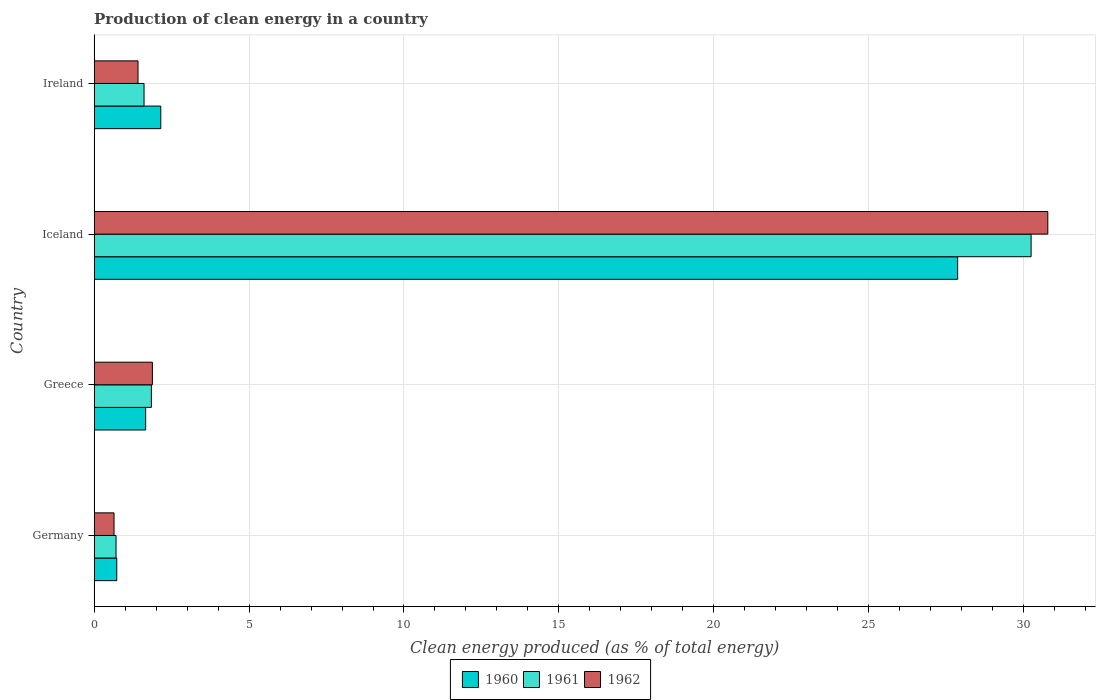How many different coloured bars are there?
Provide a succinct answer. 3. How many groups of bars are there?
Give a very brief answer. 4. How many bars are there on the 2nd tick from the top?
Provide a short and direct response. 3. How many bars are there on the 1st tick from the bottom?
Keep it short and to the point. 3. What is the label of the 1st group of bars from the top?
Provide a short and direct response. Ireland. In how many cases, is the number of bars for a given country not equal to the number of legend labels?
Offer a very short reply. 0. What is the percentage of clean energy produced in 1961 in Ireland?
Provide a succinct answer. 1.61. Across all countries, what is the maximum percentage of clean energy produced in 1961?
Give a very brief answer. 30.24. Across all countries, what is the minimum percentage of clean energy produced in 1961?
Ensure brevity in your answer.  0.7. In which country was the percentage of clean energy produced in 1961 minimum?
Keep it short and to the point. Germany. What is the total percentage of clean energy produced in 1962 in the graph?
Offer a terse response. 34.72. What is the difference between the percentage of clean energy produced in 1962 in Iceland and that in Ireland?
Your answer should be very brief. 29.37. What is the difference between the percentage of clean energy produced in 1961 in Ireland and the percentage of clean energy produced in 1962 in Germany?
Provide a short and direct response. 0.97. What is the average percentage of clean energy produced in 1962 per country?
Offer a terse response. 8.68. What is the difference between the percentage of clean energy produced in 1962 and percentage of clean energy produced in 1960 in Ireland?
Your answer should be very brief. -0.73. In how many countries, is the percentage of clean energy produced in 1962 greater than 1 %?
Keep it short and to the point. 3. What is the ratio of the percentage of clean energy produced in 1960 in Germany to that in Greece?
Your answer should be compact. 0.44. What is the difference between the highest and the second highest percentage of clean energy produced in 1961?
Offer a terse response. 28.4. What is the difference between the highest and the lowest percentage of clean energy produced in 1960?
Your answer should be very brief. 27.14. In how many countries, is the percentage of clean energy produced in 1962 greater than the average percentage of clean energy produced in 1962 taken over all countries?
Keep it short and to the point. 1. Is the sum of the percentage of clean energy produced in 1961 in Greece and Iceland greater than the maximum percentage of clean energy produced in 1960 across all countries?
Keep it short and to the point. Yes. What does the 1st bar from the top in Germany represents?
Ensure brevity in your answer.  1962. What does the 2nd bar from the bottom in Iceland represents?
Ensure brevity in your answer.  1961. Are all the bars in the graph horizontal?
Your answer should be compact. Yes. Does the graph contain grids?
Your answer should be compact. Yes. Where does the legend appear in the graph?
Provide a short and direct response. Bottom center. How many legend labels are there?
Keep it short and to the point. 3. How are the legend labels stacked?
Give a very brief answer. Horizontal. What is the title of the graph?
Your answer should be compact. Production of clean energy in a country. What is the label or title of the X-axis?
Ensure brevity in your answer.  Clean energy produced (as % of total energy). What is the Clean energy produced (as % of total energy) of 1960 in Germany?
Your response must be concise. 0.73. What is the Clean energy produced (as % of total energy) in 1961 in Germany?
Make the answer very short. 0.7. What is the Clean energy produced (as % of total energy) in 1962 in Germany?
Make the answer very short. 0.64. What is the Clean energy produced (as % of total energy) of 1960 in Greece?
Your answer should be very brief. 1.66. What is the Clean energy produced (as % of total energy) of 1961 in Greece?
Offer a very short reply. 1.84. What is the Clean energy produced (as % of total energy) in 1962 in Greece?
Your response must be concise. 1.88. What is the Clean energy produced (as % of total energy) of 1960 in Iceland?
Your answer should be compact. 27.87. What is the Clean energy produced (as % of total energy) in 1961 in Iceland?
Offer a very short reply. 30.24. What is the Clean energy produced (as % of total energy) of 1962 in Iceland?
Provide a succinct answer. 30.78. What is the Clean energy produced (as % of total energy) in 1960 in Ireland?
Make the answer very short. 2.15. What is the Clean energy produced (as % of total energy) of 1961 in Ireland?
Your answer should be compact. 1.61. What is the Clean energy produced (as % of total energy) in 1962 in Ireland?
Your answer should be compact. 1.41. Across all countries, what is the maximum Clean energy produced (as % of total energy) of 1960?
Your answer should be compact. 27.87. Across all countries, what is the maximum Clean energy produced (as % of total energy) of 1961?
Provide a short and direct response. 30.24. Across all countries, what is the maximum Clean energy produced (as % of total energy) in 1962?
Provide a short and direct response. 30.78. Across all countries, what is the minimum Clean energy produced (as % of total energy) in 1960?
Offer a very short reply. 0.73. Across all countries, what is the minimum Clean energy produced (as % of total energy) in 1961?
Provide a short and direct response. 0.7. Across all countries, what is the minimum Clean energy produced (as % of total energy) in 1962?
Your response must be concise. 0.64. What is the total Clean energy produced (as % of total energy) of 1960 in the graph?
Ensure brevity in your answer.  32.41. What is the total Clean energy produced (as % of total energy) of 1961 in the graph?
Offer a very short reply. 34.4. What is the total Clean energy produced (as % of total energy) of 1962 in the graph?
Provide a succinct answer. 34.72. What is the difference between the Clean energy produced (as % of total energy) of 1960 in Germany and that in Greece?
Your response must be concise. -0.93. What is the difference between the Clean energy produced (as % of total energy) in 1961 in Germany and that in Greece?
Make the answer very short. -1.14. What is the difference between the Clean energy produced (as % of total energy) in 1962 in Germany and that in Greece?
Your answer should be very brief. -1.24. What is the difference between the Clean energy produced (as % of total energy) of 1960 in Germany and that in Iceland?
Provide a succinct answer. -27.14. What is the difference between the Clean energy produced (as % of total energy) in 1961 in Germany and that in Iceland?
Keep it short and to the point. -29.54. What is the difference between the Clean energy produced (as % of total energy) in 1962 in Germany and that in Iceland?
Offer a very short reply. -30.14. What is the difference between the Clean energy produced (as % of total energy) in 1960 in Germany and that in Ireland?
Make the answer very short. -1.42. What is the difference between the Clean energy produced (as % of total energy) of 1961 in Germany and that in Ireland?
Give a very brief answer. -0.9. What is the difference between the Clean energy produced (as % of total energy) of 1962 in Germany and that in Ireland?
Your answer should be very brief. -0.77. What is the difference between the Clean energy produced (as % of total energy) in 1960 in Greece and that in Iceland?
Offer a very short reply. -26.21. What is the difference between the Clean energy produced (as % of total energy) in 1961 in Greece and that in Iceland?
Your answer should be compact. -28.4. What is the difference between the Clean energy produced (as % of total energy) in 1962 in Greece and that in Iceland?
Give a very brief answer. -28.9. What is the difference between the Clean energy produced (as % of total energy) of 1960 in Greece and that in Ireland?
Make the answer very short. -0.49. What is the difference between the Clean energy produced (as % of total energy) of 1961 in Greece and that in Ireland?
Your answer should be compact. 0.24. What is the difference between the Clean energy produced (as % of total energy) of 1962 in Greece and that in Ireland?
Offer a very short reply. 0.46. What is the difference between the Clean energy produced (as % of total energy) in 1960 in Iceland and that in Ireland?
Provide a short and direct response. 25.72. What is the difference between the Clean energy produced (as % of total energy) in 1961 in Iceland and that in Ireland?
Offer a terse response. 28.63. What is the difference between the Clean energy produced (as % of total energy) in 1962 in Iceland and that in Ireland?
Make the answer very short. 29.37. What is the difference between the Clean energy produced (as % of total energy) of 1960 in Germany and the Clean energy produced (as % of total energy) of 1961 in Greece?
Provide a succinct answer. -1.12. What is the difference between the Clean energy produced (as % of total energy) in 1960 in Germany and the Clean energy produced (as % of total energy) in 1962 in Greece?
Provide a succinct answer. -1.15. What is the difference between the Clean energy produced (as % of total energy) in 1961 in Germany and the Clean energy produced (as % of total energy) in 1962 in Greece?
Provide a succinct answer. -1.17. What is the difference between the Clean energy produced (as % of total energy) in 1960 in Germany and the Clean energy produced (as % of total energy) in 1961 in Iceland?
Give a very brief answer. -29.52. What is the difference between the Clean energy produced (as % of total energy) of 1960 in Germany and the Clean energy produced (as % of total energy) of 1962 in Iceland?
Offer a terse response. -30.05. What is the difference between the Clean energy produced (as % of total energy) in 1961 in Germany and the Clean energy produced (as % of total energy) in 1962 in Iceland?
Give a very brief answer. -30.08. What is the difference between the Clean energy produced (as % of total energy) of 1960 in Germany and the Clean energy produced (as % of total energy) of 1961 in Ireland?
Keep it short and to the point. -0.88. What is the difference between the Clean energy produced (as % of total energy) in 1960 in Germany and the Clean energy produced (as % of total energy) in 1962 in Ireland?
Your response must be concise. -0.69. What is the difference between the Clean energy produced (as % of total energy) of 1961 in Germany and the Clean energy produced (as % of total energy) of 1962 in Ireland?
Provide a succinct answer. -0.71. What is the difference between the Clean energy produced (as % of total energy) of 1960 in Greece and the Clean energy produced (as % of total energy) of 1961 in Iceland?
Provide a short and direct response. -28.58. What is the difference between the Clean energy produced (as % of total energy) in 1960 in Greece and the Clean energy produced (as % of total energy) in 1962 in Iceland?
Give a very brief answer. -29.12. What is the difference between the Clean energy produced (as % of total energy) of 1961 in Greece and the Clean energy produced (as % of total energy) of 1962 in Iceland?
Keep it short and to the point. -28.94. What is the difference between the Clean energy produced (as % of total energy) in 1960 in Greece and the Clean energy produced (as % of total energy) in 1961 in Ireland?
Ensure brevity in your answer.  0.05. What is the difference between the Clean energy produced (as % of total energy) of 1960 in Greece and the Clean energy produced (as % of total energy) of 1962 in Ireland?
Make the answer very short. 0.25. What is the difference between the Clean energy produced (as % of total energy) of 1961 in Greece and the Clean energy produced (as % of total energy) of 1962 in Ireland?
Your response must be concise. 0.43. What is the difference between the Clean energy produced (as % of total energy) in 1960 in Iceland and the Clean energy produced (as % of total energy) in 1961 in Ireland?
Give a very brief answer. 26.26. What is the difference between the Clean energy produced (as % of total energy) of 1960 in Iceland and the Clean energy produced (as % of total energy) of 1962 in Ireland?
Offer a very short reply. 26.46. What is the difference between the Clean energy produced (as % of total energy) of 1961 in Iceland and the Clean energy produced (as % of total energy) of 1962 in Ireland?
Provide a short and direct response. 28.83. What is the average Clean energy produced (as % of total energy) of 1960 per country?
Make the answer very short. 8.1. What is the average Clean energy produced (as % of total energy) in 1961 per country?
Ensure brevity in your answer.  8.6. What is the average Clean energy produced (as % of total energy) in 1962 per country?
Your answer should be very brief. 8.68. What is the difference between the Clean energy produced (as % of total energy) in 1960 and Clean energy produced (as % of total energy) in 1961 in Germany?
Provide a succinct answer. 0.02. What is the difference between the Clean energy produced (as % of total energy) in 1960 and Clean energy produced (as % of total energy) in 1962 in Germany?
Give a very brief answer. 0.09. What is the difference between the Clean energy produced (as % of total energy) in 1961 and Clean energy produced (as % of total energy) in 1962 in Germany?
Your answer should be very brief. 0.06. What is the difference between the Clean energy produced (as % of total energy) in 1960 and Clean energy produced (as % of total energy) in 1961 in Greece?
Provide a succinct answer. -0.18. What is the difference between the Clean energy produced (as % of total energy) in 1960 and Clean energy produced (as % of total energy) in 1962 in Greece?
Your response must be concise. -0.22. What is the difference between the Clean energy produced (as % of total energy) in 1961 and Clean energy produced (as % of total energy) in 1962 in Greece?
Your response must be concise. -0.03. What is the difference between the Clean energy produced (as % of total energy) of 1960 and Clean energy produced (as % of total energy) of 1961 in Iceland?
Make the answer very short. -2.37. What is the difference between the Clean energy produced (as % of total energy) in 1960 and Clean energy produced (as % of total energy) in 1962 in Iceland?
Offer a very short reply. -2.91. What is the difference between the Clean energy produced (as % of total energy) in 1961 and Clean energy produced (as % of total energy) in 1962 in Iceland?
Offer a terse response. -0.54. What is the difference between the Clean energy produced (as % of total energy) of 1960 and Clean energy produced (as % of total energy) of 1961 in Ireland?
Provide a short and direct response. 0.54. What is the difference between the Clean energy produced (as % of total energy) in 1960 and Clean energy produced (as % of total energy) in 1962 in Ireland?
Provide a short and direct response. 0.73. What is the difference between the Clean energy produced (as % of total energy) of 1961 and Clean energy produced (as % of total energy) of 1962 in Ireland?
Make the answer very short. 0.19. What is the ratio of the Clean energy produced (as % of total energy) in 1960 in Germany to that in Greece?
Your answer should be compact. 0.44. What is the ratio of the Clean energy produced (as % of total energy) in 1961 in Germany to that in Greece?
Provide a succinct answer. 0.38. What is the ratio of the Clean energy produced (as % of total energy) in 1962 in Germany to that in Greece?
Keep it short and to the point. 0.34. What is the ratio of the Clean energy produced (as % of total energy) of 1960 in Germany to that in Iceland?
Offer a very short reply. 0.03. What is the ratio of the Clean energy produced (as % of total energy) in 1961 in Germany to that in Iceland?
Offer a terse response. 0.02. What is the ratio of the Clean energy produced (as % of total energy) of 1962 in Germany to that in Iceland?
Ensure brevity in your answer.  0.02. What is the ratio of the Clean energy produced (as % of total energy) of 1960 in Germany to that in Ireland?
Your answer should be compact. 0.34. What is the ratio of the Clean energy produced (as % of total energy) of 1961 in Germany to that in Ireland?
Keep it short and to the point. 0.44. What is the ratio of the Clean energy produced (as % of total energy) of 1962 in Germany to that in Ireland?
Provide a succinct answer. 0.45. What is the ratio of the Clean energy produced (as % of total energy) in 1960 in Greece to that in Iceland?
Your response must be concise. 0.06. What is the ratio of the Clean energy produced (as % of total energy) of 1961 in Greece to that in Iceland?
Your answer should be very brief. 0.06. What is the ratio of the Clean energy produced (as % of total energy) of 1962 in Greece to that in Iceland?
Provide a short and direct response. 0.06. What is the ratio of the Clean energy produced (as % of total energy) of 1960 in Greece to that in Ireland?
Your response must be concise. 0.77. What is the ratio of the Clean energy produced (as % of total energy) in 1961 in Greece to that in Ireland?
Offer a terse response. 1.15. What is the ratio of the Clean energy produced (as % of total energy) in 1962 in Greece to that in Ireland?
Your answer should be compact. 1.33. What is the ratio of the Clean energy produced (as % of total energy) in 1960 in Iceland to that in Ireland?
Ensure brevity in your answer.  12.97. What is the ratio of the Clean energy produced (as % of total energy) of 1961 in Iceland to that in Ireland?
Ensure brevity in your answer.  18.79. What is the ratio of the Clean energy produced (as % of total energy) in 1962 in Iceland to that in Ireland?
Your answer should be very brief. 21.76. What is the difference between the highest and the second highest Clean energy produced (as % of total energy) of 1960?
Ensure brevity in your answer.  25.72. What is the difference between the highest and the second highest Clean energy produced (as % of total energy) of 1961?
Your answer should be compact. 28.4. What is the difference between the highest and the second highest Clean energy produced (as % of total energy) of 1962?
Provide a succinct answer. 28.9. What is the difference between the highest and the lowest Clean energy produced (as % of total energy) of 1960?
Your answer should be very brief. 27.14. What is the difference between the highest and the lowest Clean energy produced (as % of total energy) in 1961?
Keep it short and to the point. 29.54. What is the difference between the highest and the lowest Clean energy produced (as % of total energy) in 1962?
Ensure brevity in your answer.  30.14. 